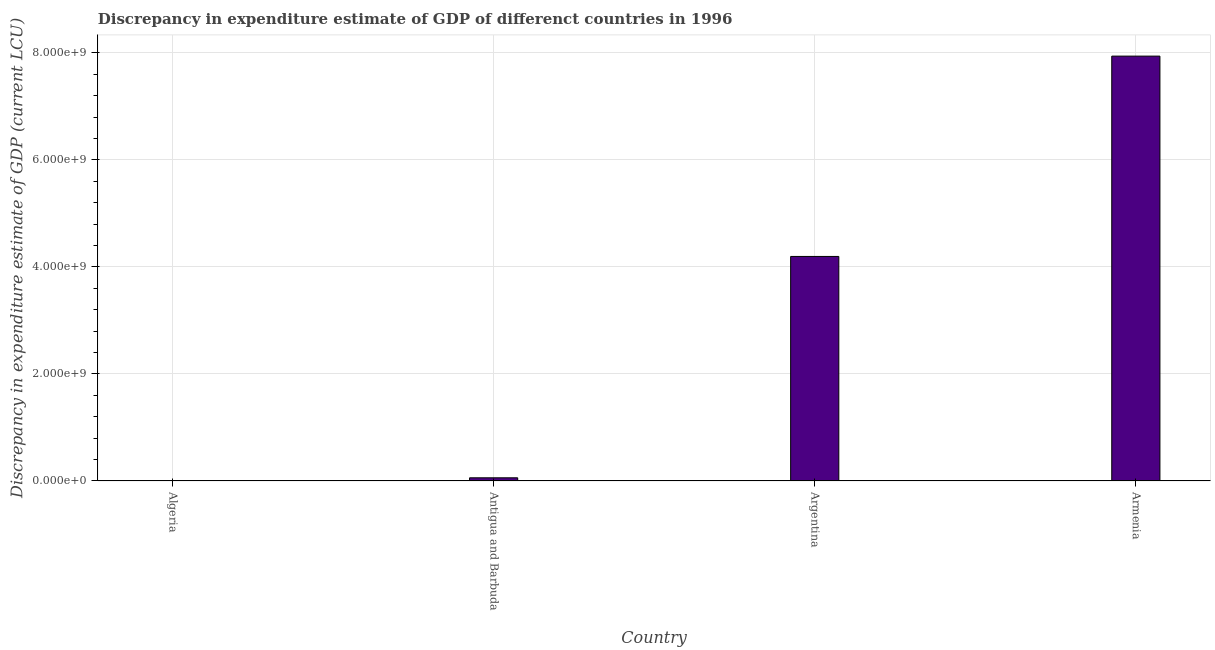Does the graph contain any zero values?
Ensure brevity in your answer.  No. What is the title of the graph?
Give a very brief answer. Discrepancy in expenditure estimate of GDP of differenct countries in 1996. What is the label or title of the Y-axis?
Offer a very short reply. Discrepancy in expenditure estimate of GDP (current LCU). What is the discrepancy in expenditure estimate of gdp in Antigua and Barbuda?
Provide a succinct answer. 5.97e+07. Across all countries, what is the maximum discrepancy in expenditure estimate of gdp?
Your answer should be very brief. 7.94e+09. Across all countries, what is the minimum discrepancy in expenditure estimate of gdp?
Your answer should be very brief. 1.31e+05. In which country was the discrepancy in expenditure estimate of gdp maximum?
Your answer should be compact. Armenia. In which country was the discrepancy in expenditure estimate of gdp minimum?
Your answer should be compact. Algeria. What is the sum of the discrepancy in expenditure estimate of gdp?
Provide a short and direct response. 1.22e+1. What is the difference between the discrepancy in expenditure estimate of gdp in Algeria and Antigua and Barbuda?
Provide a succinct answer. -5.96e+07. What is the average discrepancy in expenditure estimate of gdp per country?
Provide a succinct answer. 3.05e+09. What is the median discrepancy in expenditure estimate of gdp?
Keep it short and to the point. 2.13e+09. What is the ratio of the discrepancy in expenditure estimate of gdp in Argentina to that in Armenia?
Ensure brevity in your answer.  0.53. Is the discrepancy in expenditure estimate of gdp in Antigua and Barbuda less than that in Armenia?
Offer a terse response. Yes. Is the difference between the discrepancy in expenditure estimate of gdp in Algeria and Armenia greater than the difference between any two countries?
Give a very brief answer. Yes. What is the difference between the highest and the second highest discrepancy in expenditure estimate of gdp?
Give a very brief answer. 3.74e+09. Is the sum of the discrepancy in expenditure estimate of gdp in Antigua and Barbuda and Argentina greater than the maximum discrepancy in expenditure estimate of gdp across all countries?
Offer a very short reply. No. What is the difference between the highest and the lowest discrepancy in expenditure estimate of gdp?
Keep it short and to the point. 7.94e+09. How many bars are there?
Offer a terse response. 4. Are all the bars in the graph horizontal?
Your response must be concise. No. How many countries are there in the graph?
Your response must be concise. 4. What is the Discrepancy in expenditure estimate of GDP (current LCU) in Algeria?
Offer a very short reply. 1.31e+05. What is the Discrepancy in expenditure estimate of GDP (current LCU) in Antigua and Barbuda?
Your response must be concise. 5.97e+07. What is the Discrepancy in expenditure estimate of GDP (current LCU) in Argentina?
Your response must be concise. 4.20e+09. What is the Discrepancy in expenditure estimate of GDP (current LCU) in Armenia?
Provide a short and direct response. 7.94e+09. What is the difference between the Discrepancy in expenditure estimate of GDP (current LCU) in Algeria and Antigua and Barbuda?
Your answer should be compact. -5.96e+07. What is the difference between the Discrepancy in expenditure estimate of GDP (current LCU) in Algeria and Argentina?
Ensure brevity in your answer.  -4.20e+09. What is the difference between the Discrepancy in expenditure estimate of GDP (current LCU) in Algeria and Armenia?
Give a very brief answer. -7.94e+09. What is the difference between the Discrepancy in expenditure estimate of GDP (current LCU) in Antigua and Barbuda and Argentina?
Your answer should be compact. -4.14e+09. What is the difference between the Discrepancy in expenditure estimate of GDP (current LCU) in Antigua and Barbuda and Armenia?
Give a very brief answer. -7.88e+09. What is the difference between the Discrepancy in expenditure estimate of GDP (current LCU) in Argentina and Armenia?
Your answer should be very brief. -3.74e+09. What is the ratio of the Discrepancy in expenditure estimate of GDP (current LCU) in Algeria to that in Antigua and Barbuda?
Provide a succinct answer. 0. What is the ratio of the Discrepancy in expenditure estimate of GDP (current LCU) in Antigua and Barbuda to that in Argentina?
Provide a short and direct response. 0.01. What is the ratio of the Discrepancy in expenditure estimate of GDP (current LCU) in Antigua and Barbuda to that in Armenia?
Your answer should be very brief. 0.01. What is the ratio of the Discrepancy in expenditure estimate of GDP (current LCU) in Argentina to that in Armenia?
Keep it short and to the point. 0.53. 